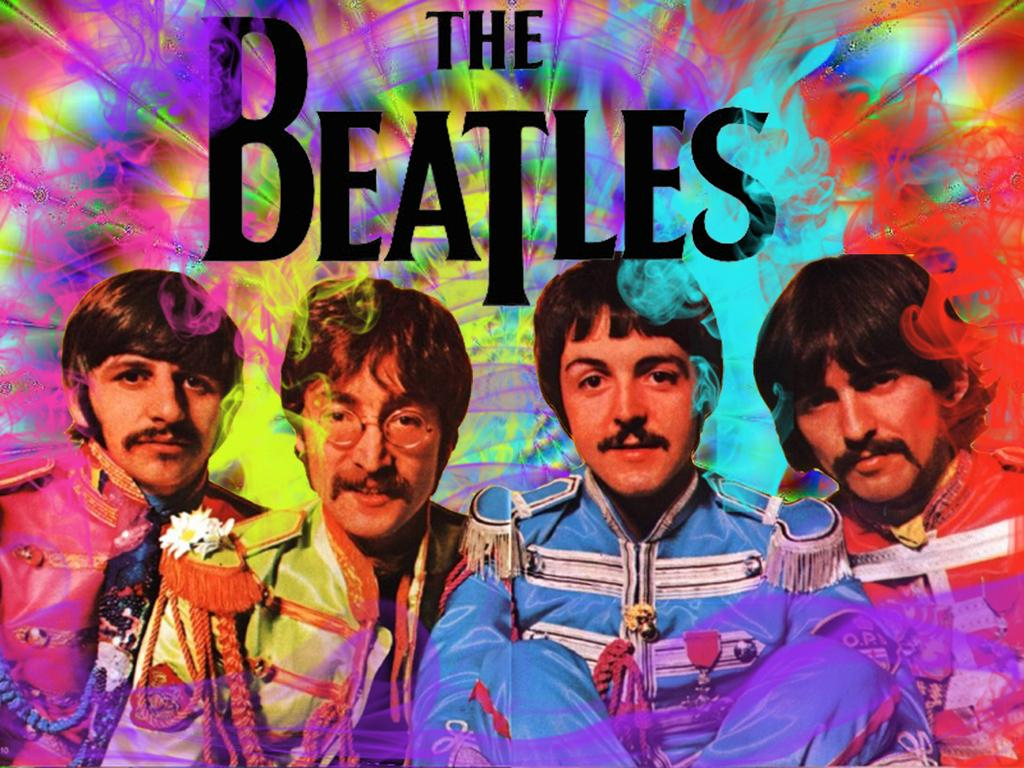How many people are present in the image? There are four people in the image. What else can be seen in the image besides the people? There is text in the image. What type of animals can be seen in the wilderness in the image? There is no wilderness or animals present in the image; it features four people and text. 